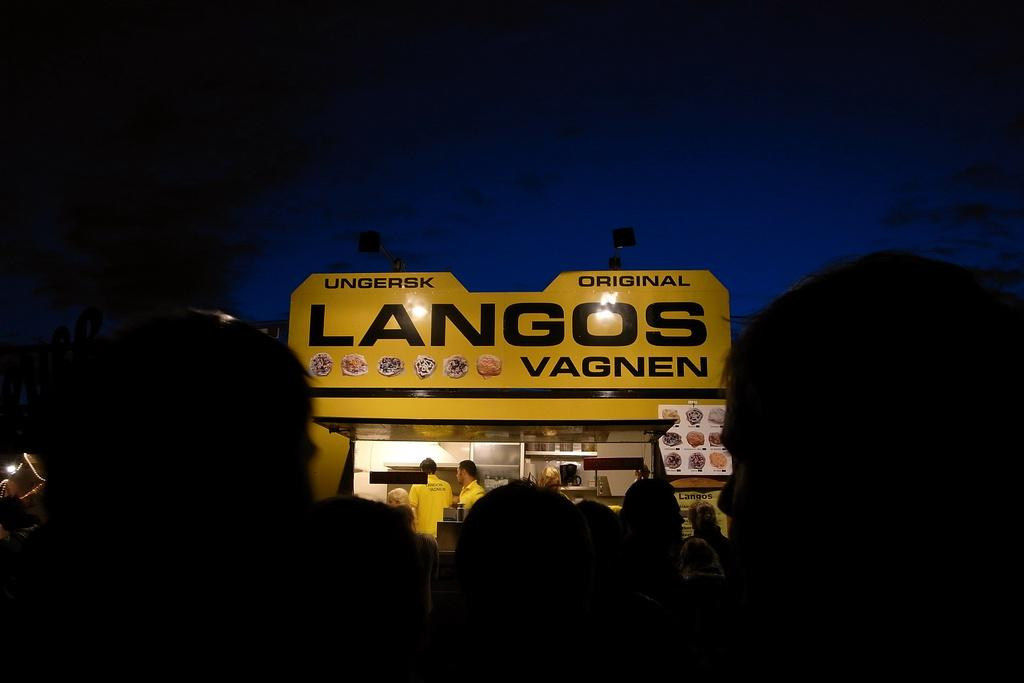How many people are in the image? There is a group of people in the image. Can you describe the people in the front of the group? There are three people in front of the group. What else can be seen in the image besides the people? There are posters, lights, and some objects in the image. What is visible in the background of the image? The sky is visible in the background of the image. What type of pipe is being played by the pig in the image? There is no pig or pipe present in the image. Can you describe the cloud formation in the image? There are no clouds visible in the image; only the sky is visible in the background. 